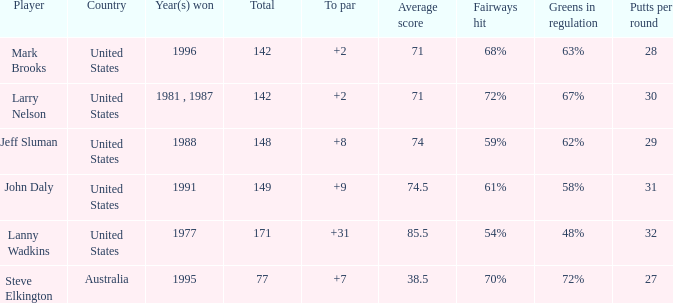Name the To par that has a Year(s) won of 1988 and a Total smaller than 148? None. 